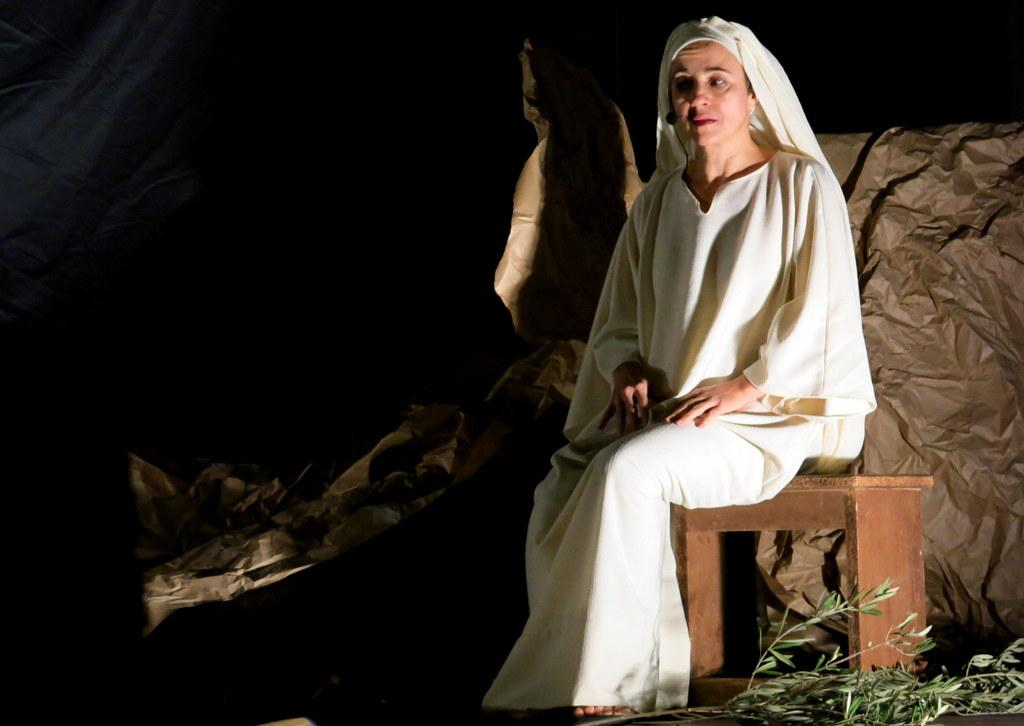What is the woman in the image doing? The woman is sitting on a stool in the image. What can be seen at the bottom of the image? The branches of a plant are visible at the bottom of the image. How would you describe the lighting in the image? The background of the image is dark. What else can be seen in the image besides the woman and the plant? Objects are visible in the background of the image. What type of badge is the woman wearing in the image? There is no badge visible on the woman in the image. What vegetables are being used as decoration in the image? There are no vegetables present in the image. 